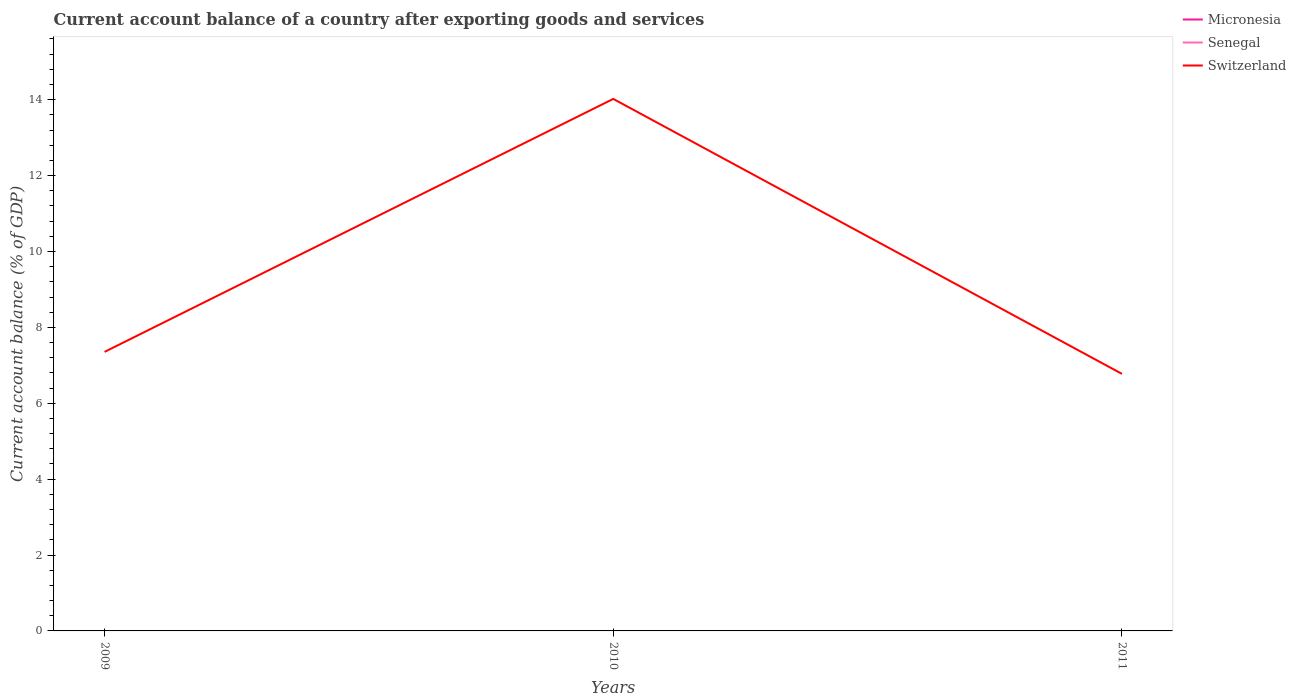How many different coloured lines are there?
Offer a terse response. 1. Is the number of lines equal to the number of legend labels?
Ensure brevity in your answer.  No. Across all years, what is the maximum account balance in Senegal?
Your answer should be compact. 0. What is the total account balance in Switzerland in the graph?
Offer a terse response. -6.67. What is the difference between the highest and the second highest account balance in Switzerland?
Your answer should be very brief. 7.25. What is the difference between the highest and the lowest account balance in Switzerland?
Your answer should be compact. 1. How many lines are there?
Provide a short and direct response. 1. What is the difference between two consecutive major ticks on the Y-axis?
Keep it short and to the point. 2. Are the values on the major ticks of Y-axis written in scientific E-notation?
Offer a terse response. No. Does the graph contain any zero values?
Offer a very short reply. Yes. Does the graph contain grids?
Your answer should be compact. No. Where does the legend appear in the graph?
Keep it short and to the point. Top right. How many legend labels are there?
Provide a short and direct response. 3. How are the legend labels stacked?
Ensure brevity in your answer.  Vertical. What is the title of the graph?
Keep it short and to the point. Current account balance of a country after exporting goods and services. Does "Australia" appear as one of the legend labels in the graph?
Provide a succinct answer. No. What is the label or title of the X-axis?
Make the answer very short. Years. What is the label or title of the Y-axis?
Your answer should be very brief. Current account balance (% of GDP). What is the Current account balance (% of GDP) of Micronesia in 2009?
Keep it short and to the point. 0. What is the Current account balance (% of GDP) in Switzerland in 2009?
Your answer should be very brief. 7.35. What is the Current account balance (% of GDP) in Micronesia in 2010?
Keep it short and to the point. 0. What is the Current account balance (% of GDP) in Switzerland in 2010?
Your response must be concise. 14.02. What is the Current account balance (% of GDP) in Switzerland in 2011?
Your answer should be compact. 6.77. Across all years, what is the maximum Current account balance (% of GDP) of Switzerland?
Provide a succinct answer. 14.02. Across all years, what is the minimum Current account balance (% of GDP) of Switzerland?
Provide a short and direct response. 6.77. What is the total Current account balance (% of GDP) of Senegal in the graph?
Your answer should be very brief. 0. What is the total Current account balance (% of GDP) of Switzerland in the graph?
Provide a succinct answer. 28.15. What is the difference between the Current account balance (% of GDP) in Switzerland in 2009 and that in 2010?
Provide a succinct answer. -6.67. What is the difference between the Current account balance (% of GDP) in Switzerland in 2009 and that in 2011?
Your answer should be compact. 0.58. What is the difference between the Current account balance (% of GDP) in Switzerland in 2010 and that in 2011?
Give a very brief answer. 7.25. What is the average Current account balance (% of GDP) of Micronesia per year?
Offer a terse response. 0. What is the average Current account balance (% of GDP) of Senegal per year?
Make the answer very short. 0. What is the average Current account balance (% of GDP) in Switzerland per year?
Your answer should be compact. 9.38. What is the ratio of the Current account balance (% of GDP) in Switzerland in 2009 to that in 2010?
Offer a very short reply. 0.52. What is the ratio of the Current account balance (% of GDP) of Switzerland in 2009 to that in 2011?
Offer a very short reply. 1.09. What is the ratio of the Current account balance (% of GDP) of Switzerland in 2010 to that in 2011?
Make the answer very short. 2.07. What is the difference between the highest and the lowest Current account balance (% of GDP) of Switzerland?
Provide a short and direct response. 7.25. 